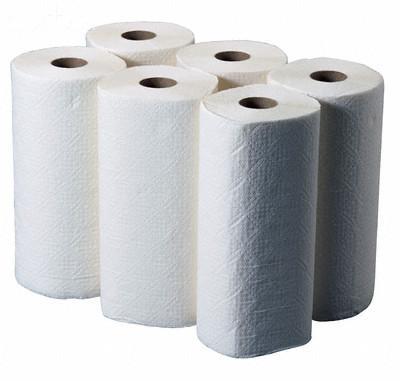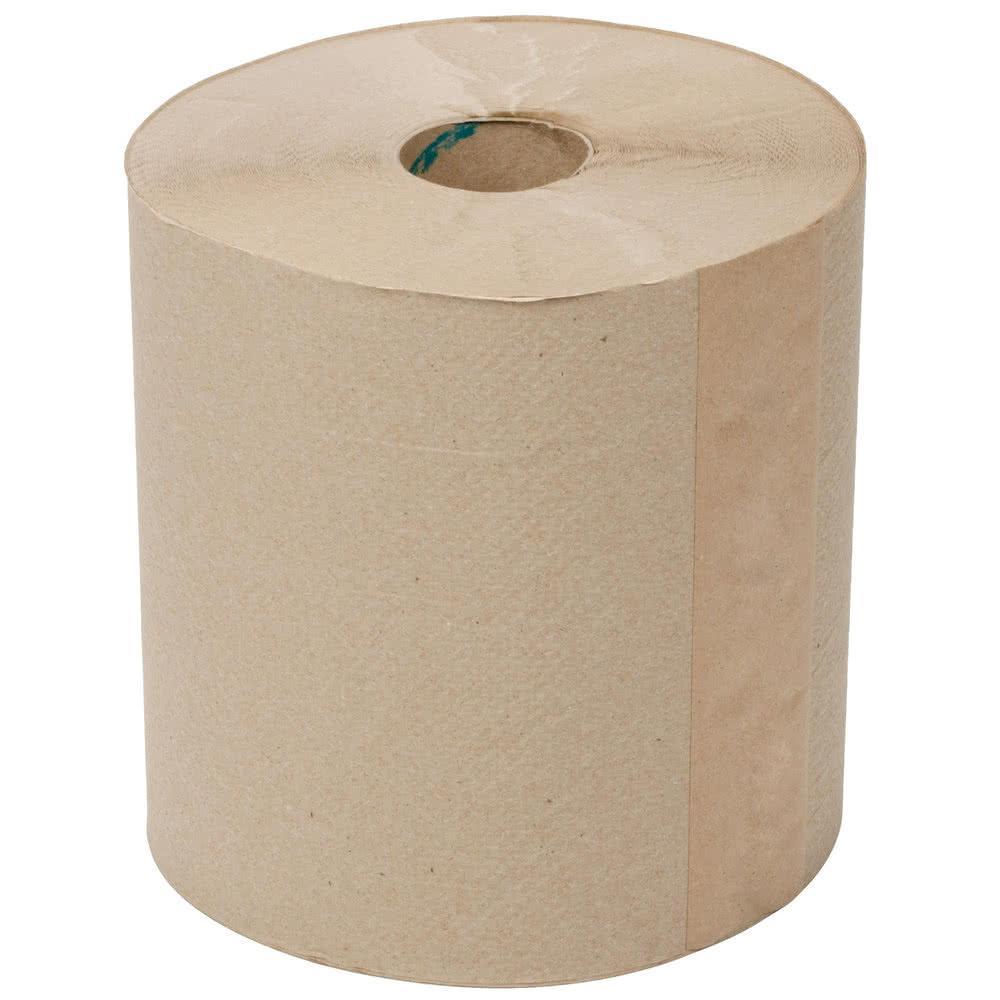The first image is the image on the left, the second image is the image on the right. Considering the images on both sides, is "One roll of paper towels is brown and at least three are white." valid? Answer yes or no. Yes. The first image is the image on the left, the second image is the image on the right. For the images displayed, is the sentence "There are no less than three rolls of paper towels in the image on the left." factually correct? Answer yes or no. Yes. The first image is the image on the left, the second image is the image on the right. Evaluate the accuracy of this statement regarding the images: "The left image contains at least five paper rolls.". Is it true? Answer yes or no. Yes. 